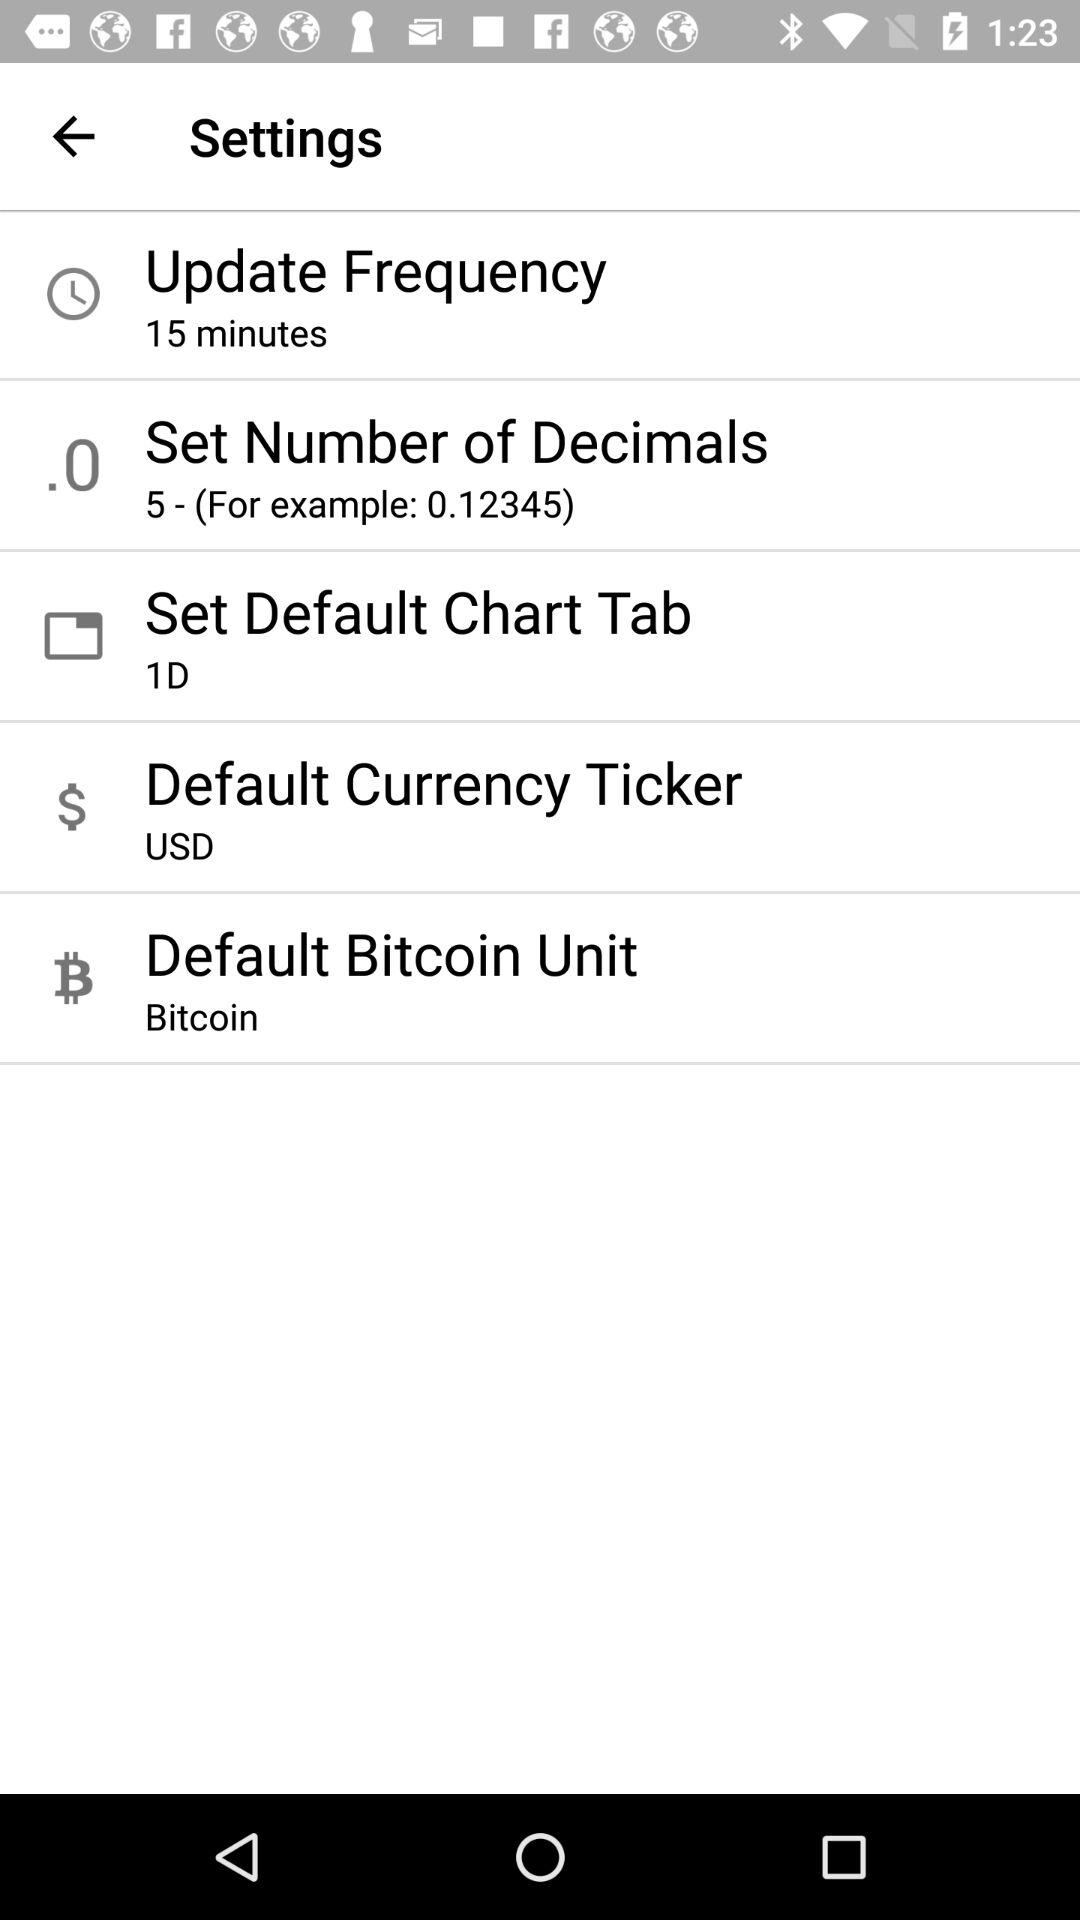What's the default currency ticker? The default currency ticker is USD. 